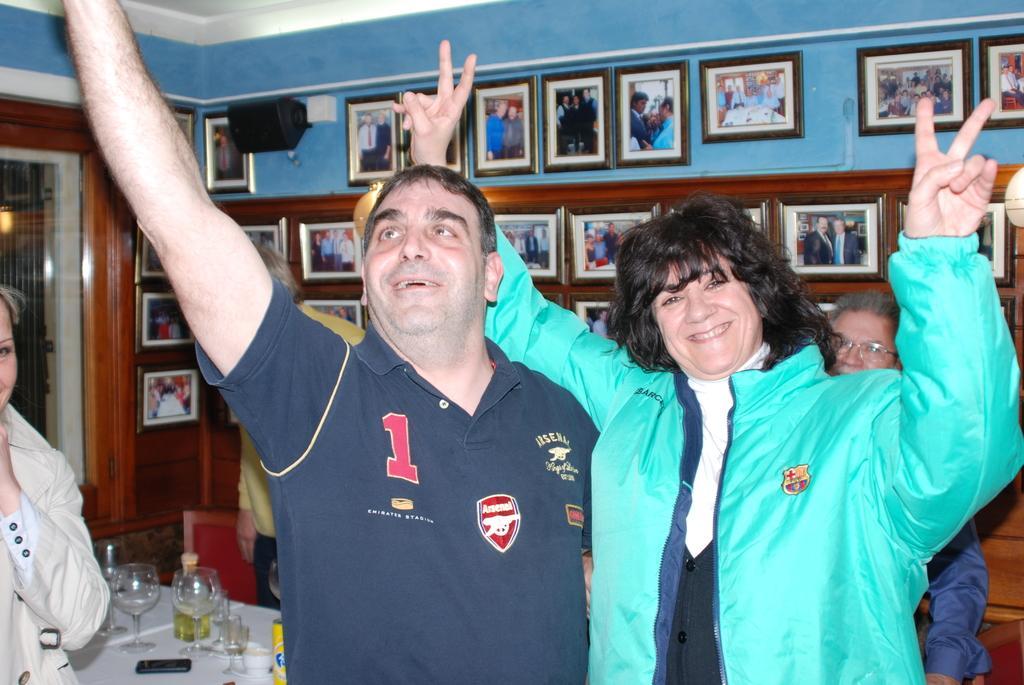In one or two sentences, can you explain what this image depicts? In the center of the image we can see a man and a lady smiling. In the background there are many photo frames placed on the wall. On the left there is a lady. At the bottom we can see a table. There are many glasses and a mobile placed on the table. On the right there is a man. In the background there is a door. 